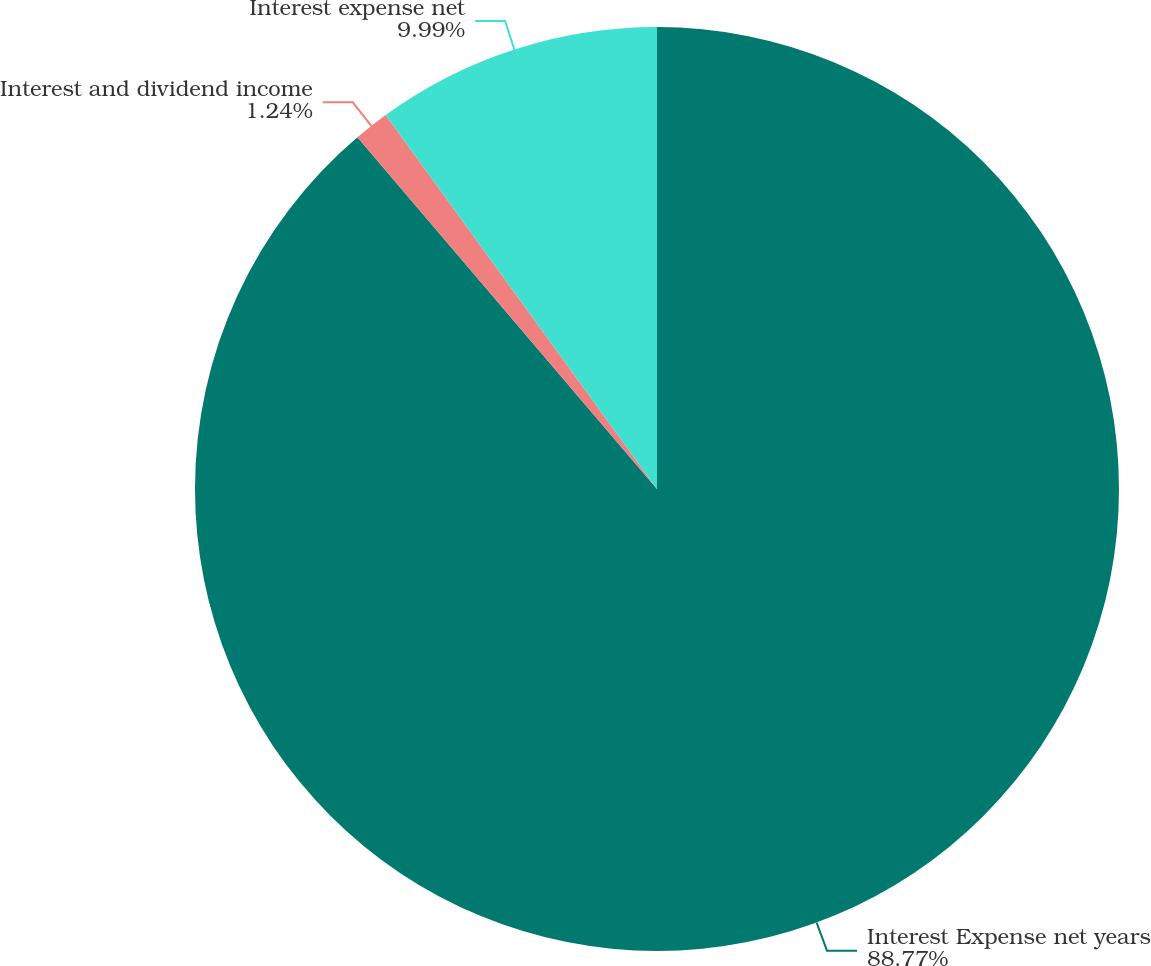Convert chart to OTSL. <chart><loc_0><loc_0><loc_500><loc_500><pie_chart><fcel>Interest Expense net years<fcel>Interest and dividend income<fcel>Interest expense net<nl><fcel>88.77%<fcel>1.24%<fcel>9.99%<nl></chart> 